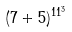Convert formula to latex. <formula><loc_0><loc_0><loc_500><loc_500>( 7 + 5 ) ^ { 1 1 ^ { 3 } }</formula> 